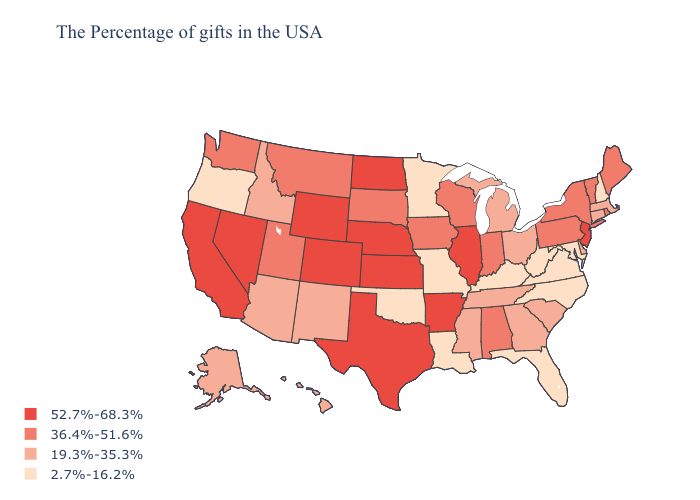Among the states that border Indiana , does Illinois have the highest value?
Answer briefly. Yes. Name the states that have a value in the range 36.4%-51.6%?
Quick response, please. Maine, Rhode Island, Vermont, New York, Pennsylvania, Indiana, Alabama, Wisconsin, Iowa, South Dakota, Utah, Montana, Washington. Among the states that border Kentucky , does Virginia have the highest value?
Be succinct. No. What is the value of Iowa?
Write a very short answer. 36.4%-51.6%. Does Missouri have the highest value in the USA?
Be succinct. No. Does Nebraska have the highest value in the MidWest?
Quick response, please. Yes. What is the value of Ohio?
Keep it brief. 19.3%-35.3%. What is the value of Alaska?
Keep it brief. 19.3%-35.3%. Does Nevada have the highest value in the West?
Give a very brief answer. Yes. Does New Jersey have a higher value than Colorado?
Quick response, please. No. What is the lowest value in the MidWest?
Keep it brief. 2.7%-16.2%. Name the states that have a value in the range 36.4%-51.6%?
Give a very brief answer. Maine, Rhode Island, Vermont, New York, Pennsylvania, Indiana, Alabama, Wisconsin, Iowa, South Dakota, Utah, Montana, Washington. What is the value of Utah?
Keep it brief. 36.4%-51.6%. Does the map have missing data?
Quick response, please. No. What is the highest value in the MidWest ?
Write a very short answer. 52.7%-68.3%. 